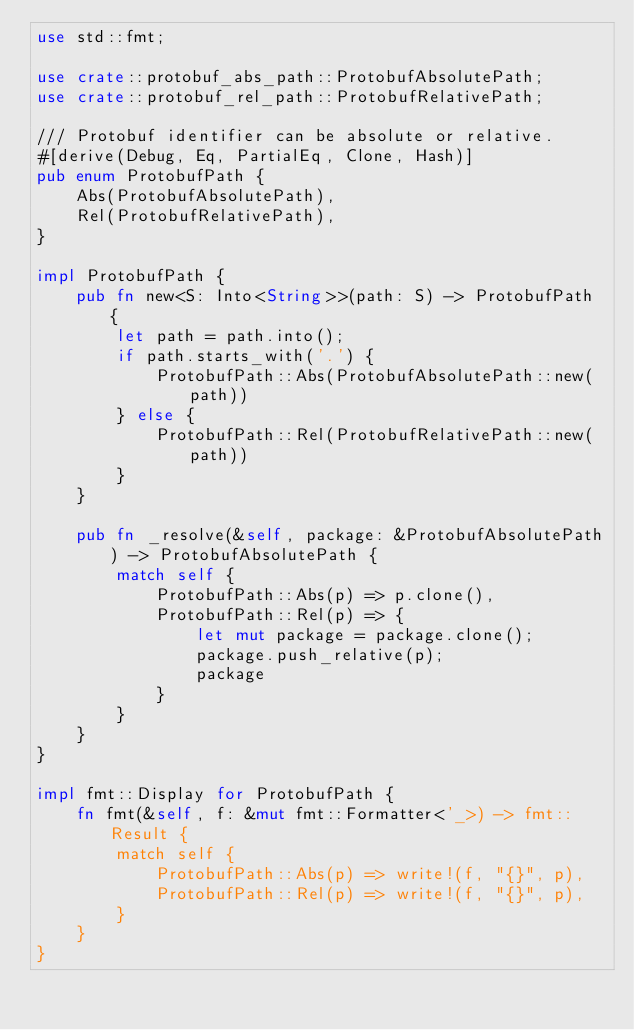Convert code to text. <code><loc_0><loc_0><loc_500><loc_500><_Rust_>use std::fmt;

use crate::protobuf_abs_path::ProtobufAbsolutePath;
use crate::protobuf_rel_path::ProtobufRelativePath;

/// Protobuf identifier can be absolute or relative.
#[derive(Debug, Eq, PartialEq, Clone, Hash)]
pub enum ProtobufPath {
    Abs(ProtobufAbsolutePath),
    Rel(ProtobufRelativePath),
}

impl ProtobufPath {
    pub fn new<S: Into<String>>(path: S) -> ProtobufPath {
        let path = path.into();
        if path.starts_with('.') {
            ProtobufPath::Abs(ProtobufAbsolutePath::new(path))
        } else {
            ProtobufPath::Rel(ProtobufRelativePath::new(path))
        }
    }

    pub fn _resolve(&self, package: &ProtobufAbsolutePath) -> ProtobufAbsolutePath {
        match self {
            ProtobufPath::Abs(p) => p.clone(),
            ProtobufPath::Rel(p) => {
                let mut package = package.clone();
                package.push_relative(p);
                package
            }
        }
    }
}

impl fmt::Display for ProtobufPath {
    fn fmt(&self, f: &mut fmt::Formatter<'_>) -> fmt::Result {
        match self {
            ProtobufPath::Abs(p) => write!(f, "{}", p),
            ProtobufPath::Rel(p) => write!(f, "{}", p),
        }
    }
}
</code> 